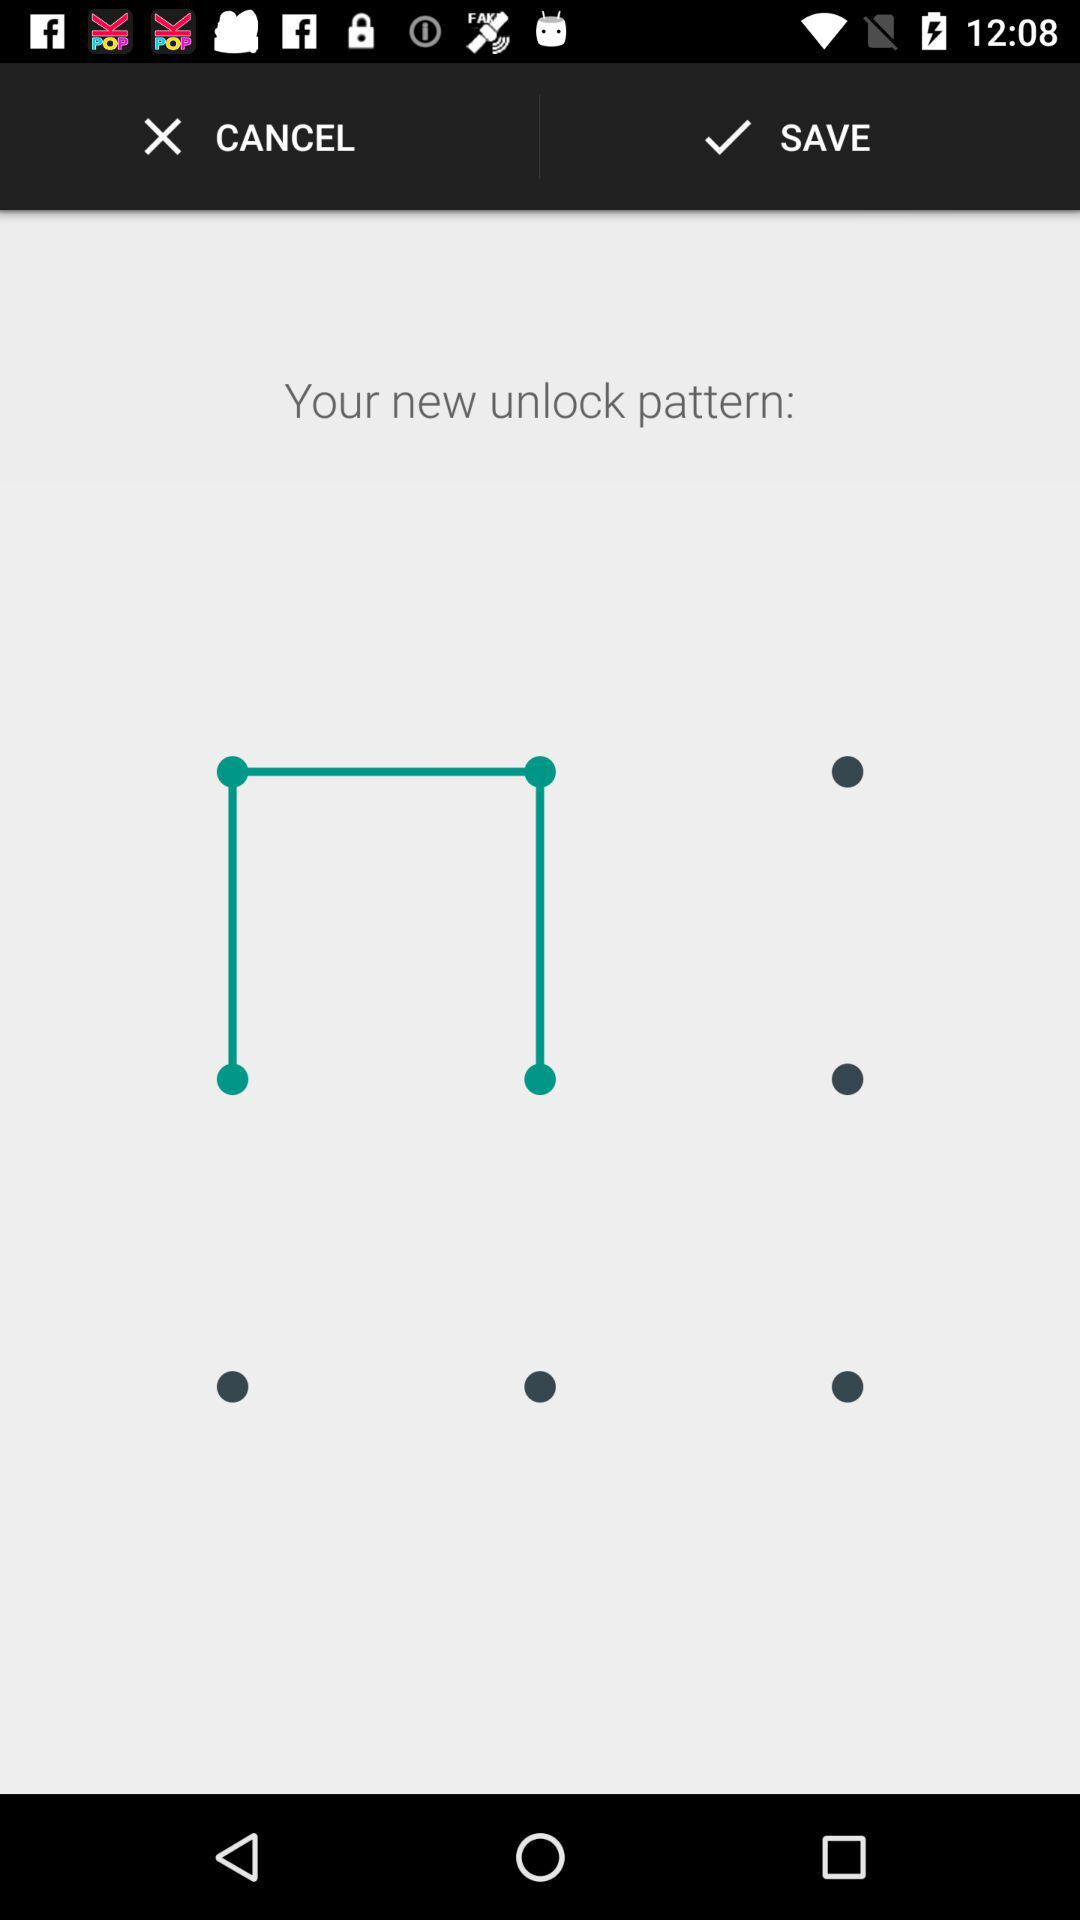How many circles are there in the pattern?
Answer the question using a single word or phrase. 4 